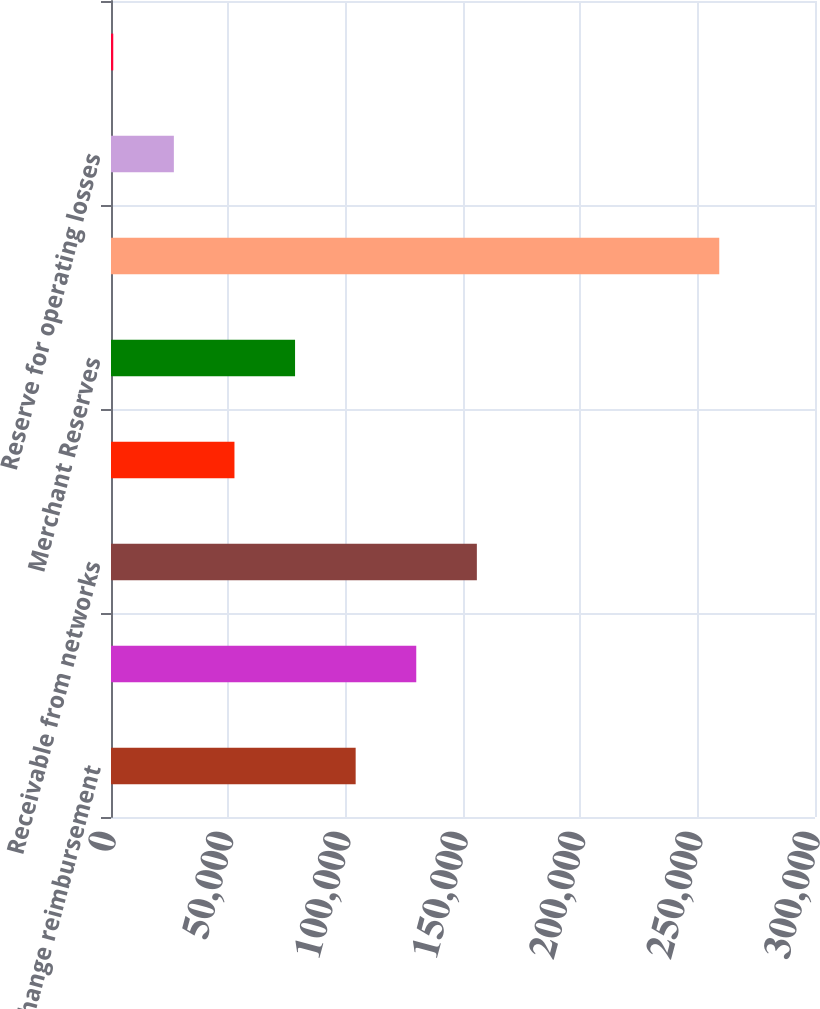<chart> <loc_0><loc_0><loc_500><loc_500><bar_chart><fcel>Interchange reimbursement<fcel>Receivable from Members<fcel>Receivable from networks<fcel>Exception items<fcel>Merchant Reserves<fcel>Total<fcel>Reserve for operating losses<fcel>Reserves for sales allowances<nl><fcel>104258<fcel>130082<fcel>155907<fcel>52609.6<fcel>78433.9<fcel>259204<fcel>26785.3<fcel>961<nl></chart> 